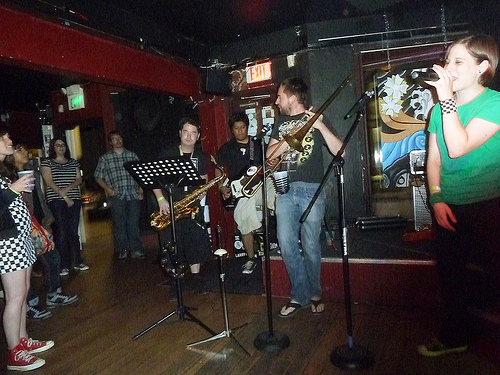<image>
Is there a woman on the mike? Yes. Looking at the image, I can see the woman is positioned on top of the mike, with the mike providing support. 